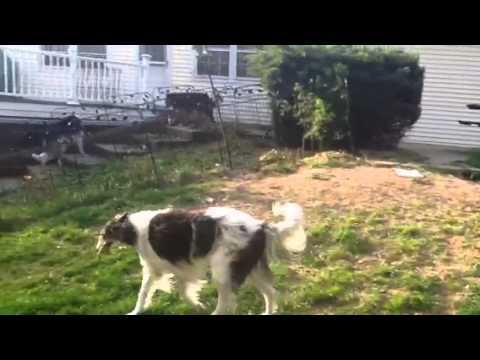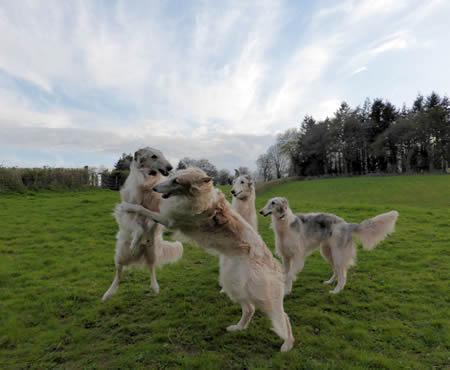The first image is the image on the left, the second image is the image on the right. Given the left and right images, does the statement "At least one person is outside with the dogs in the image on the right." hold true? Answer yes or no. No. 